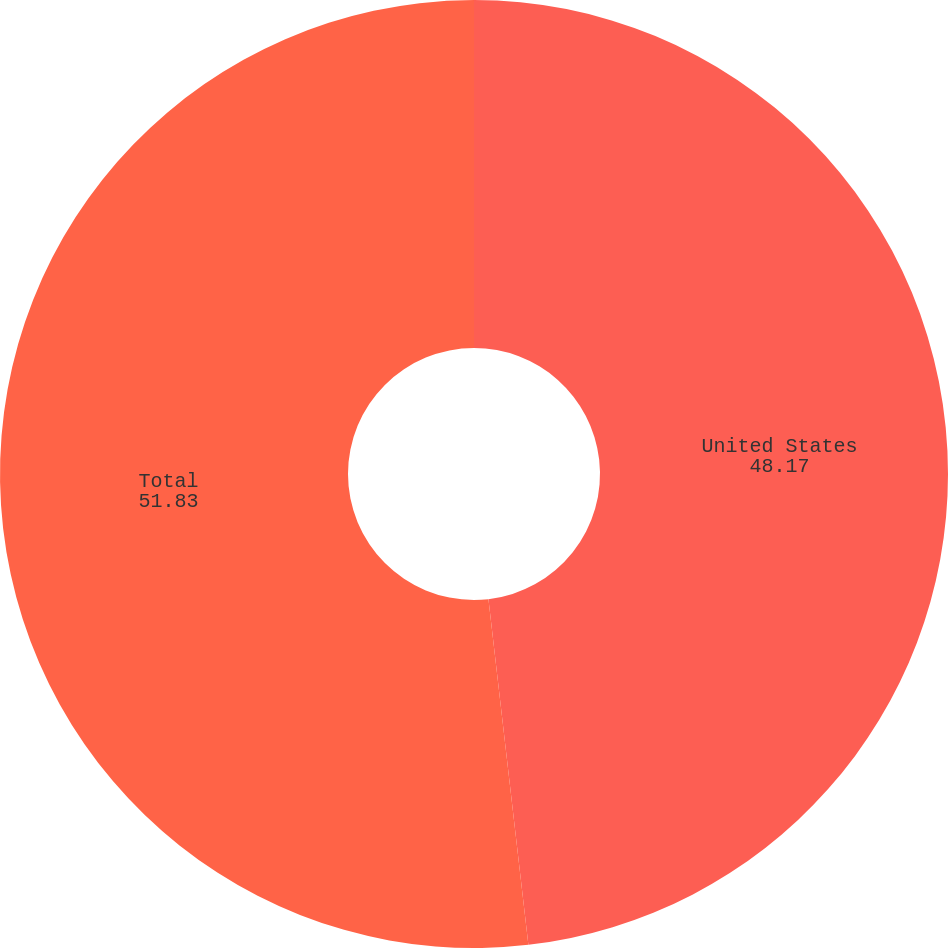<chart> <loc_0><loc_0><loc_500><loc_500><pie_chart><fcel>United States<fcel>Total<nl><fcel>48.17%<fcel>51.83%<nl></chart> 